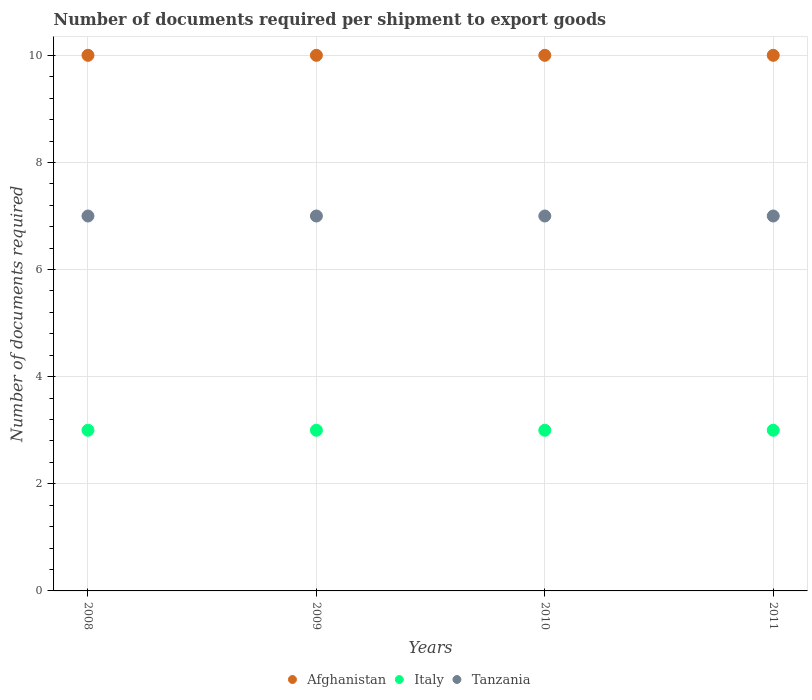How many different coloured dotlines are there?
Make the answer very short. 3. Is the number of dotlines equal to the number of legend labels?
Offer a terse response. Yes. What is the number of documents required per shipment to export goods in Tanzania in 2010?
Your answer should be compact. 7. Across all years, what is the maximum number of documents required per shipment to export goods in Italy?
Your answer should be very brief. 3. Across all years, what is the minimum number of documents required per shipment to export goods in Tanzania?
Ensure brevity in your answer.  7. In which year was the number of documents required per shipment to export goods in Italy maximum?
Offer a terse response. 2008. In which year was the number of documents required per shipment to export goods in Italy minimum?
Give a very brief answer. 2008. What is the total number of documents required per shipment to export goods in Italy in the graph?
Ensure brevity in your answer.  12. What is the difference between the number of documents required per shipment to export goods in Italy in 2010 and the number of documents required per shipment to export goods in Afghanistan in 2009?
Your response must be concise. -7. What is the average number of documents required per shipment to export goods in Afghanistan per year?
Provide a short and direct response. 10. In the year 2011, what is the difference between the number of documents required per shipment to export goods in Afghanistan and number of documents required per shipment to export goods in Tanzania?
Keep it short and to the point. 3. Is the number of documents required per shipment to export goods in Afghanistan in 2008 less than that in 2010?
Make the answer very short. No. Is the difference between the number of documents required per shipment to export goods in Afghanistan in 2009 and 2011 greater than the difference between the number of documents required per shipment to export goods in Tanzania in 2009 and 2011?
Give a very brief answer. No. What is the difference between the highest and the second highest number of documents required per shipment to export goods in Italy?
Offer a terse response. 0. In how many years, is the number of documents required per shipment to export goods in Afghanistan greater than the average number of documents required per shipment to export goods in Afghanistan taken over all years?
Provide a succinct answer. 0. Is the sum of the number of documents required per shipment to export goods in Afghanistan in 2008 and 2010 greater than the maximum number of documents required per shipment to export goods in Tanzania across all years?
Make the answer very short. Yes. Is it the case that in every year, the sum of the number of documents required per shipment to export goods in Italy and number of documents required per shipment to export goods in Tanzania  is greater than the number of documents required per shipment to export goods in Afghanistan?
Make the answer very short. No. Does the number of documents required per shipment to export goods in Tanzania monotonically increase over the years?
Offer a very short reply. No. How many years are there in the graph?
Provide a short and direct response. 4. Does the graph contain any zero values?
Ensure brevity in your answer.  No. Does the graph contain grids?
Make the answer very short. Yes. Where does the legend appear in the graph?
Keep it short and to the point. Bottom center. What is the title of the graph?
Provide a succinct answer. Number of documents required per shipment to export goods. What is the label or title of the Y-axis?
Your response must be concise. Number of documents required. What is the Number of documents required of Italy in 2008?
Offer a terse response. 3. What is the Number of documents required in Tanzania in 2008?
Give a very brief answer. 7. What is the Number of documents required of Afghanistan in 2009?
Provide a short and direct response. 10. What is the Number of documents required of Afghanistan in 2010?
Ensure brevity in your answer.  10. What is the Number of documents required of Italy in 2010?
Provide a succinct answer. 3. What is the Number of documents required of Tanzania in 2010?
Your response must be concise. 7. What is the Number of documents required in Afghanistan in 2011?
Your response must be concise. 10. What is the Number of documents required in Italy in 2011?
Offer a terse response. 3. What is the Number of documents required in Tanzania in 2011?
Keep it short and to the point. 7. Across all years, what is the maximum Number of documents required of Afghanistan?
Provide a short and direct response. 10. Across all years, what is the minimum Number of documents required of Afghanistan?
Provide a short and direct response. 10. Across all years, what is the minimum Number of documents required of Italy?
Provide a short and direct response. 3. What is the total Number of documents required in Afghanistan in the graph?
Offer a terse response. 40. What is the total Number of documents required of Tanzania in the graph?
Give a very brief answer. 28. What is the difference between the Number of documents required of Italy in 2008 and that in 2009?
Offer a very short reply. 0. What is the difference between the Number of documents required of Afghanistan in 2009 and that in 2011?
Provide a short and direct response. 0. What is the difference between the Number of documents required in Tanzania in 2009 and that in 2011?
Give a very brief answer. 0. What is the difference between the Number of documents required of Italy in 2010 and that in 2011?
Offer a very short reply. 0. What is the difference between the Number of documents required in Tanzania in 2010 and that in 2011?
Provide a succinct answer. 0. What is the difference between the Number of documents required in Afghanistan in 2008 and the Number of documents required in Tanzania in 2009?
Keep it short and to the point. 3. What is the difference between the Number of documents required in Italy in 2008 and the Number of documents required in Tanzania in 2009?
Ensure brevity in your answer.  -4. What is the difference between the Number of documents required of Afghanistan in 2008 and the Number of documents required of Italy in 2010?
Ensure brevity in your answer.  7. What is the difference between the Number of documents required of Italy in 2008 and the Number of documents required of Tanzania in 2010?
Give a very brief answer. -4. What is the difference between the Number of documents required of Afghanistan in 2008 and the Number of documents required of Italy in 2011?
Provide a succinct answer. 7. What is the difference between the Number of documents required in Afghanistan in 2008 and the Number of documents required in Tanzania in 2011?
Make the answer very short. 3. What is the difference between the Number of documents required in Afghanistan in 2009 and the Number of documents required in Italy in 2010?
Give a very brief answer. 7. What is the difference between the Number of documents required of Italy in 2009 and the Number of documents required of Tanzania in 2010?
Make the answer very short. -4. What is the difference between the Number of documents required of Italy in 2010 and the Number of documents required of Tanzania in 2011?
Offer a terse response. -4. What is the average Number of documents required of Afghanistan per year?
Keep it short and to the point. 10. In the year 2008, what is the difference between the Number of documents required of Afghanistan and Number of documents required of Tanzania?
Keep it short and to the point. 3. In the year 2009, what is the difference between the Number of documents required of Afghanistan and Number of documents required of Tanzania?
Your answer should be compact. 3. In the year 2010, what is the difference between the Number of documents required of Afghanistan and Number of documents required of Italy?
Offer a very short reply. 7. In the year 2010, what is the difference between the Number of documents required in Italy and Number of documents required in Tanzania?
Your answer should be compact. -4. What is the ratio of the Number of documents required in Afghanistan in 2008 to that in 2009?
Ensure brevity in your answer.  1. What is the ratio of the Number of documents required of Italy in 2008 to that in 2009?
Provide a succinct answer. 1. What is the ratio of the Number of documents required in Tanzania in 2008 to that in 2009?
Ensure brevity in your answer.  1. What is the ratio of the Number of documents required in Tanzania in 2008 to that in 2010?
Provide a succinct answer. 1. What is the ratio of the Number of documents required of Afghanistan in 2008 to that in 2011?
Provide a succinct answer. 1. What is the ratio of the Number of documents required in Tanzania in 2008 to that in 2011?
Your answer should be very brief. 1. What is the ratio of the Number of documents required of Afghanistan in 2009 to that in 2011?
Your answer should be very brief. 1. What is the ratio of the Number of documents required in Tanzania in 2009 to that in 2011?
Give a very brief answer. 1. What is the ratio of the Number of documents required of Tanzania in 2010 to that in 2011?
Your answer should be compact. 1. What is the difference between the highest and the second highest Number of documents required of Afghanistan?
Your answer should be very brief. 0. What is the difference between the highest and the second highest Number of documents required in Italy?
Make the answer very short. 0. What is the difference between the highest and the second highest Number of documents required of Tanzania?
Keep it short and to the point. 0. 